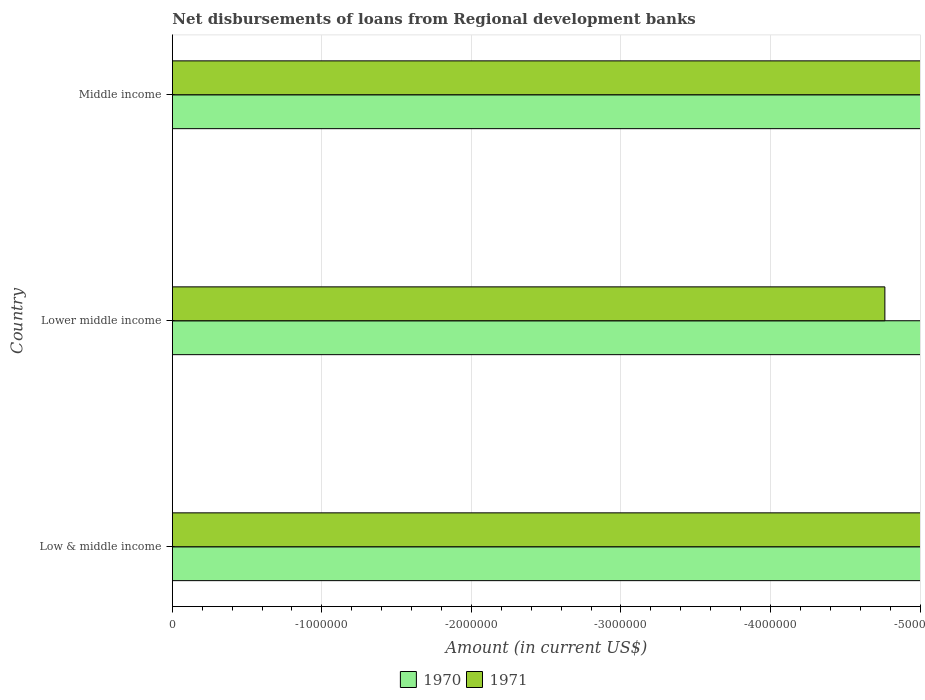How many different coloured bars are there?
Provide a succinct answer. 0. Are the number of bars per tick equal to the number of legend labels?
Your answer should be very brief. No. Are the number of bars on each tick of the Y-axis equal?
Your response must be concise. Yes. What is the label of the 2nd group of bars from the top?
Make the answer very short. Lower middle income. In how many cases, is the number of bars for a given country not equal to the number of legend labels?
Your answer should be very brief. 3. Are all the bars in the graph horizontal?
Give a very brief answer. Yes. How many countries are there in the graph?
Make the answer very short. 3. Are the values on the major ticks of X-axis written in scientific E-notation?
Your answer should be compact. No. Does the graph contain any zero values?
Give a very brief answer. Yes. What is the title of the graph?
Provide a short and direct response. Net disbursements of loans from Regional development banks. What is the label or title of the X-axis?
Offer a terse response. Amount (in current US$). What is the Amount (in current US$) in 1970 in Low & middle income?
Provide a succinct answer. 0. What is the Amount (in current US$) of 1971 in Lower middle income?
Provide a short and direct response. 0. What is the Amount (in current US$) in 1970 in Middle income?
Make the answer very short. 0. What is the total Amount (in current US$) of 1970 in the graph?
Give a very brief answer. 0. What is the average Amount (in current US$) in 1970 per country?
Make the answer very short. 0. What is the average Amount (in current US$) in 1971 per country?
Provide a succinct answer. 0. 